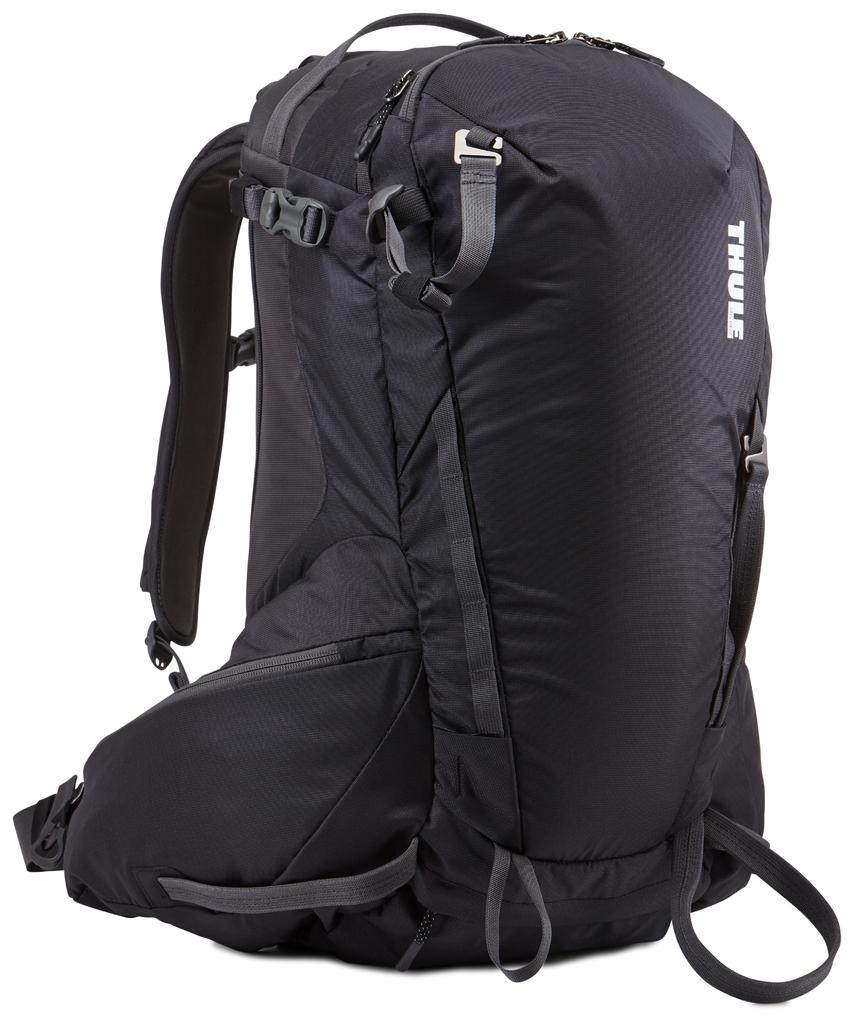<image>
Present a compact description of the photo's key features. Large black backpack with the word "THULE" in white. 